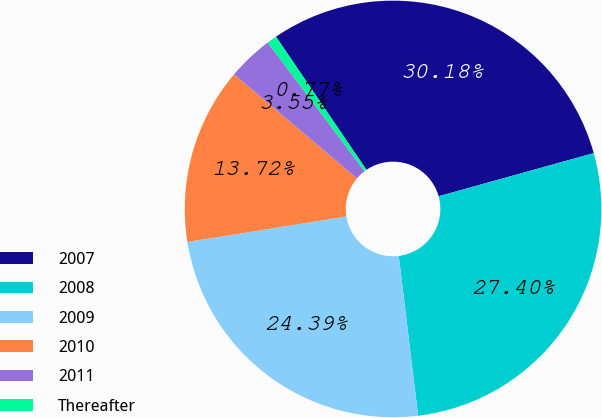<chart> <loc_0><loc_0><loc_500><loc_500><pie_chart><fcel>2007<fcel>2008<fcel>2009<fcel>2010<fcel>2011<fcel>Thereafter<nl><fcel>30.18%<fcel>27.4%<fcel>24.39%<fcel>13.72%<fcel>3.55%<fcel>0.77%<nl></chart> 